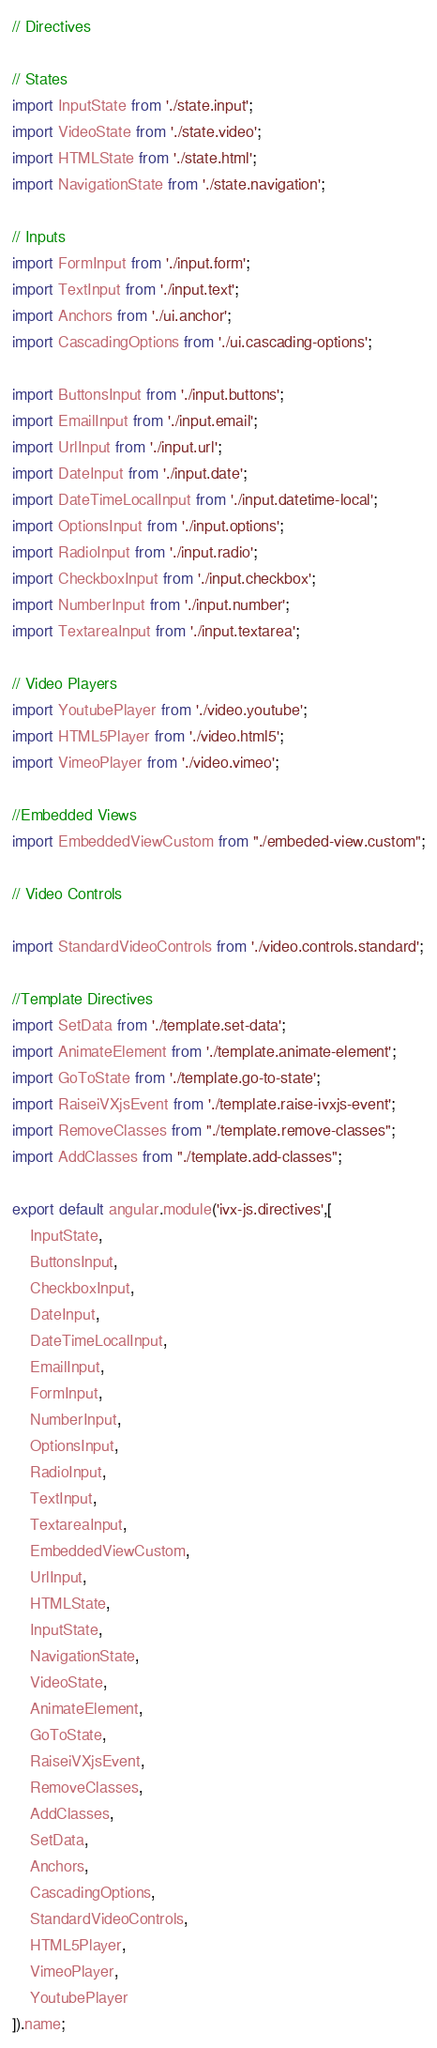Convert code to text. <code><loc_0><loc_0><loc_500><loc_500><_JavaScript_>// Directives

// States
import InputState from './state.input';
import VideoState from './state.video';
import HTMLState from './state.html';
import NavigationState from './state.navigation';

// Inputs
import FormInput from './input.form';
import TextInput from './input.text';
import Anchors from './ui.anchor';
import CascadingOptions from './ui.cascading-options';

import ButtonsInput from './input.buttons';
import EmailInput from './input.email';
import UrlInput from './input.url';
import DateInput from './input.date';
import DateTimeLocalInput from './input.datetime-local';
import OptionsInput from './input.options';
import RadioInput from './input.radio';
import CheckboxInput from './input.checkbox';
import NumberInput from './input.number';
import TextareaInput from './input.textarea';

// Video Players
import YoutubePlayer from './video.youtube';
import HTML5Player from './video.html5';
import VimeoPlayer from './video.vimeo';

//Embedded Views
import EmbeddedViewCustom from "./embeded-view.custom";

// Video Controls

import StandardVideoControls from './video.controls.standard';

//Template Directives 
import SetData from './template.set-data';
import AnimateElement from './template.animate-element';
import GoToState from './template.go-to-state';
import RaiseiVXjsEvent from './template.raise-ivxjs-event';
import RemoveClasses from "./template.remove-classes";
import AddClasses from "./template.add-classes";

export default angular.module('ivx-js.directives',[
    InputState,
    ButtonsInput,
    CheckboxInput,
    DateInput,
    DateTimeLocalInput,
    EmailInput,
    FormInput,
    NumberInput,
    OptionsInput,
    RadioInput,
    TextInput,
    TextareaInput,
    EmbeddedViewCustom,
    UrlInput,
    HTMLState,
    InputState,
    NavigationState,
    VideoState,
    AnimateElement,
    GoToState,
    RaiseiVXjsEvent,
    RemoveClasses,
    AddClasses,
    SetData,
    Anchors,
    CascadingOptions,
    StandardVideoControls,
    HTML5Player,
    VimeoPlayer,
    YoutubePlayer
]).name;</code> 